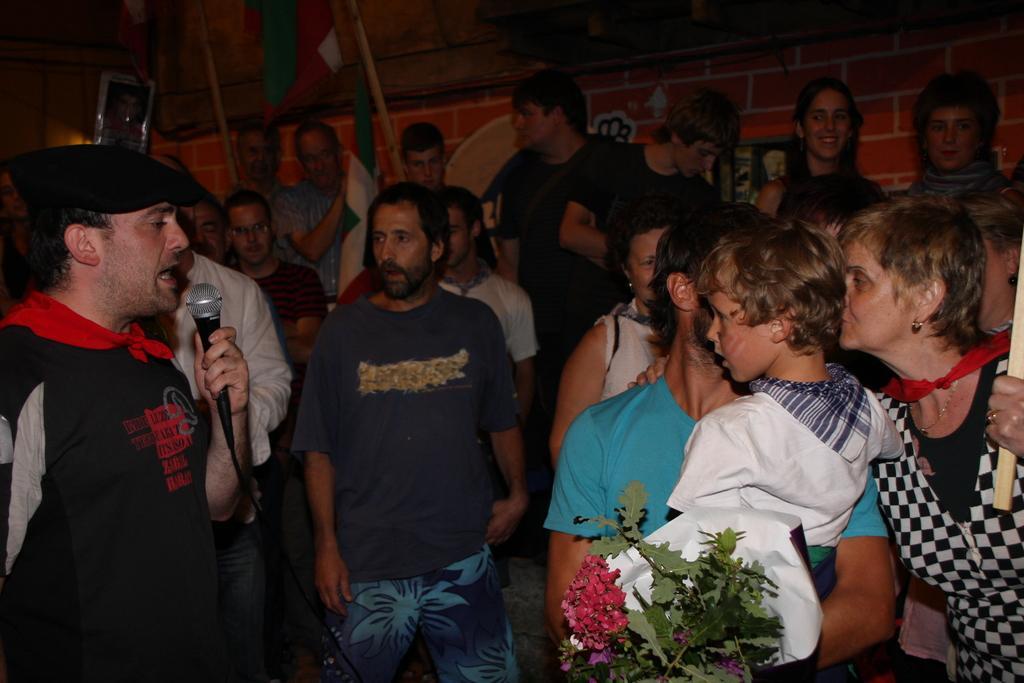Describe this image in one or two sentences. There is a group of people. On the left side we have a black color shirt person. His holding a mic and his talking. Everyone listening to him. We can see in the background there is a wall,flag and flower vase. 